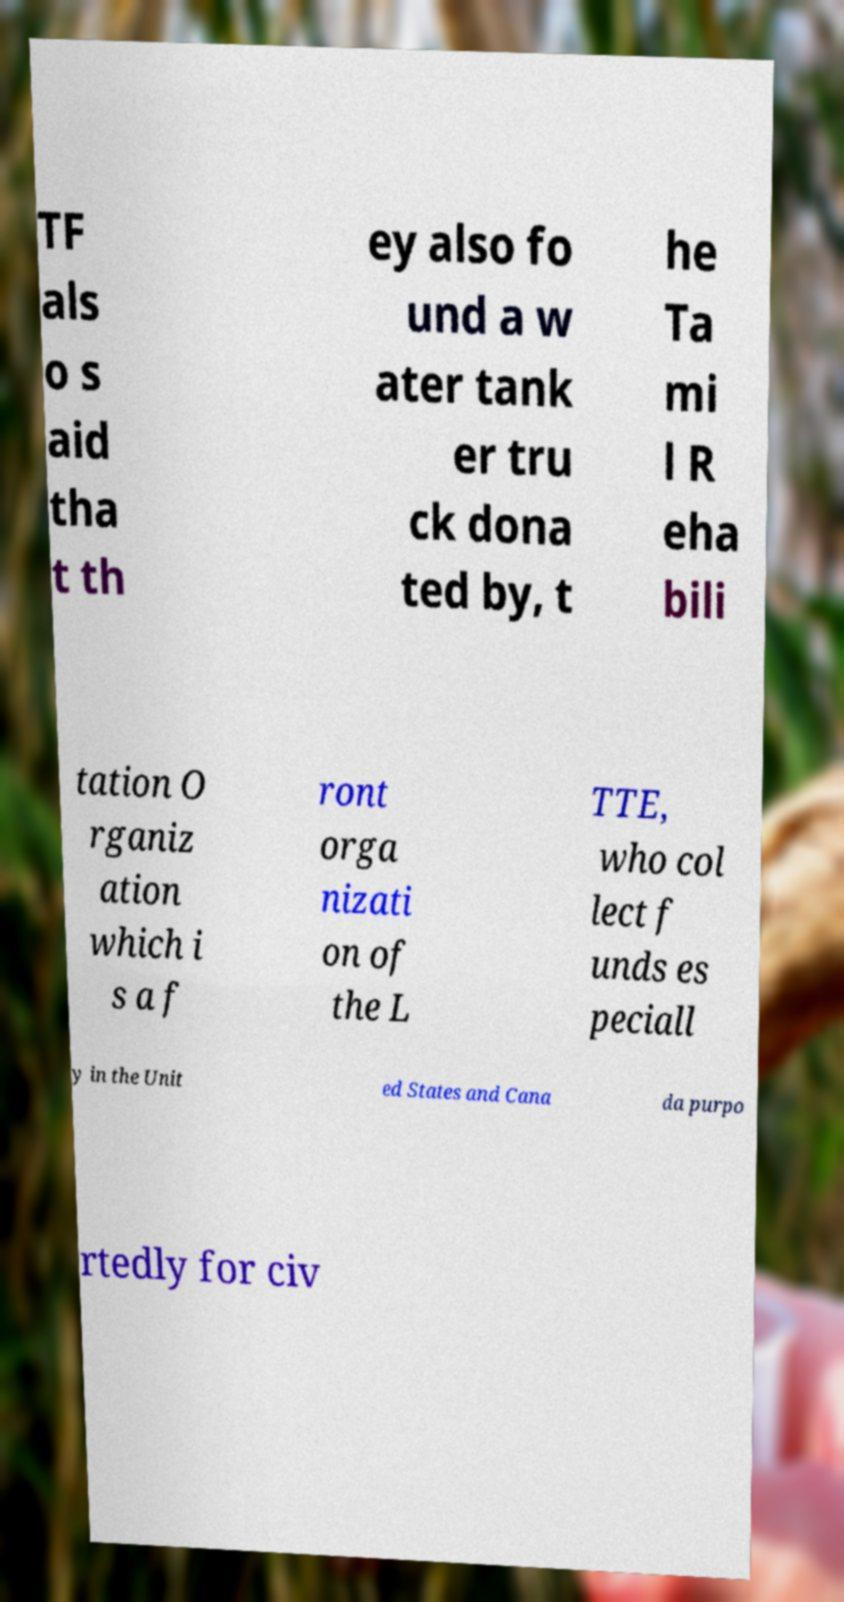For documentation purposes, I need the text within this image transcribed. Could you provide that? TF als o s aid tha t th ey also fo und a w ater tank er tru ck dona ted by, t he Ta mi l R eha bili tation O rganiz ation which i s a f ront orga nizati on of the L TTE, who col lect f unds es peciall y in the Unit ed States and Cana da purpo rtedly for civ 